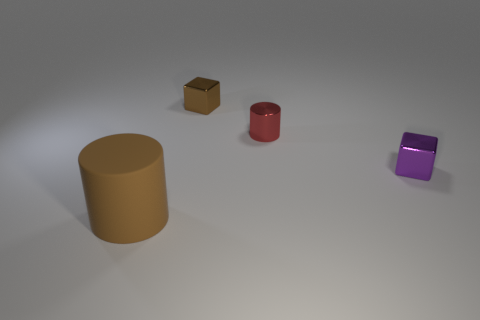Add 2 gray matte blocks. How many objects exist? 6 Subtract 2 cylinders. How many cylinders are left? 0 Add 2 tiny purple shiny things. How many tiny purple shiny things are left? 3 Add 4 cylinders. How many cylinders exist? 6 Subtract all brown cylinders. How many cylinders are left? 1 Subtract 0 green cubes. How many objects are left? 4 Subtract all purple blocks. Subtract all yellow balls. How many blocks are left? 1 Subtract all green cylinders. How many red cubes are left? 0 Subtract all big gray rubber blocks. Subtract all brown matte things. How many objects are left? 3 